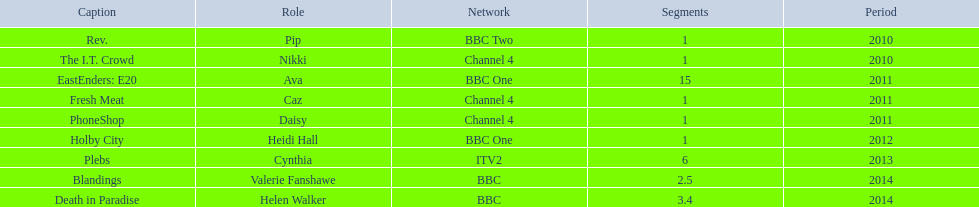How many episodes did sophie colquhoun star in on rev.? 1. What character did she play on phoneshop? Daisy. What role did she play on itv2? Cynthia. 